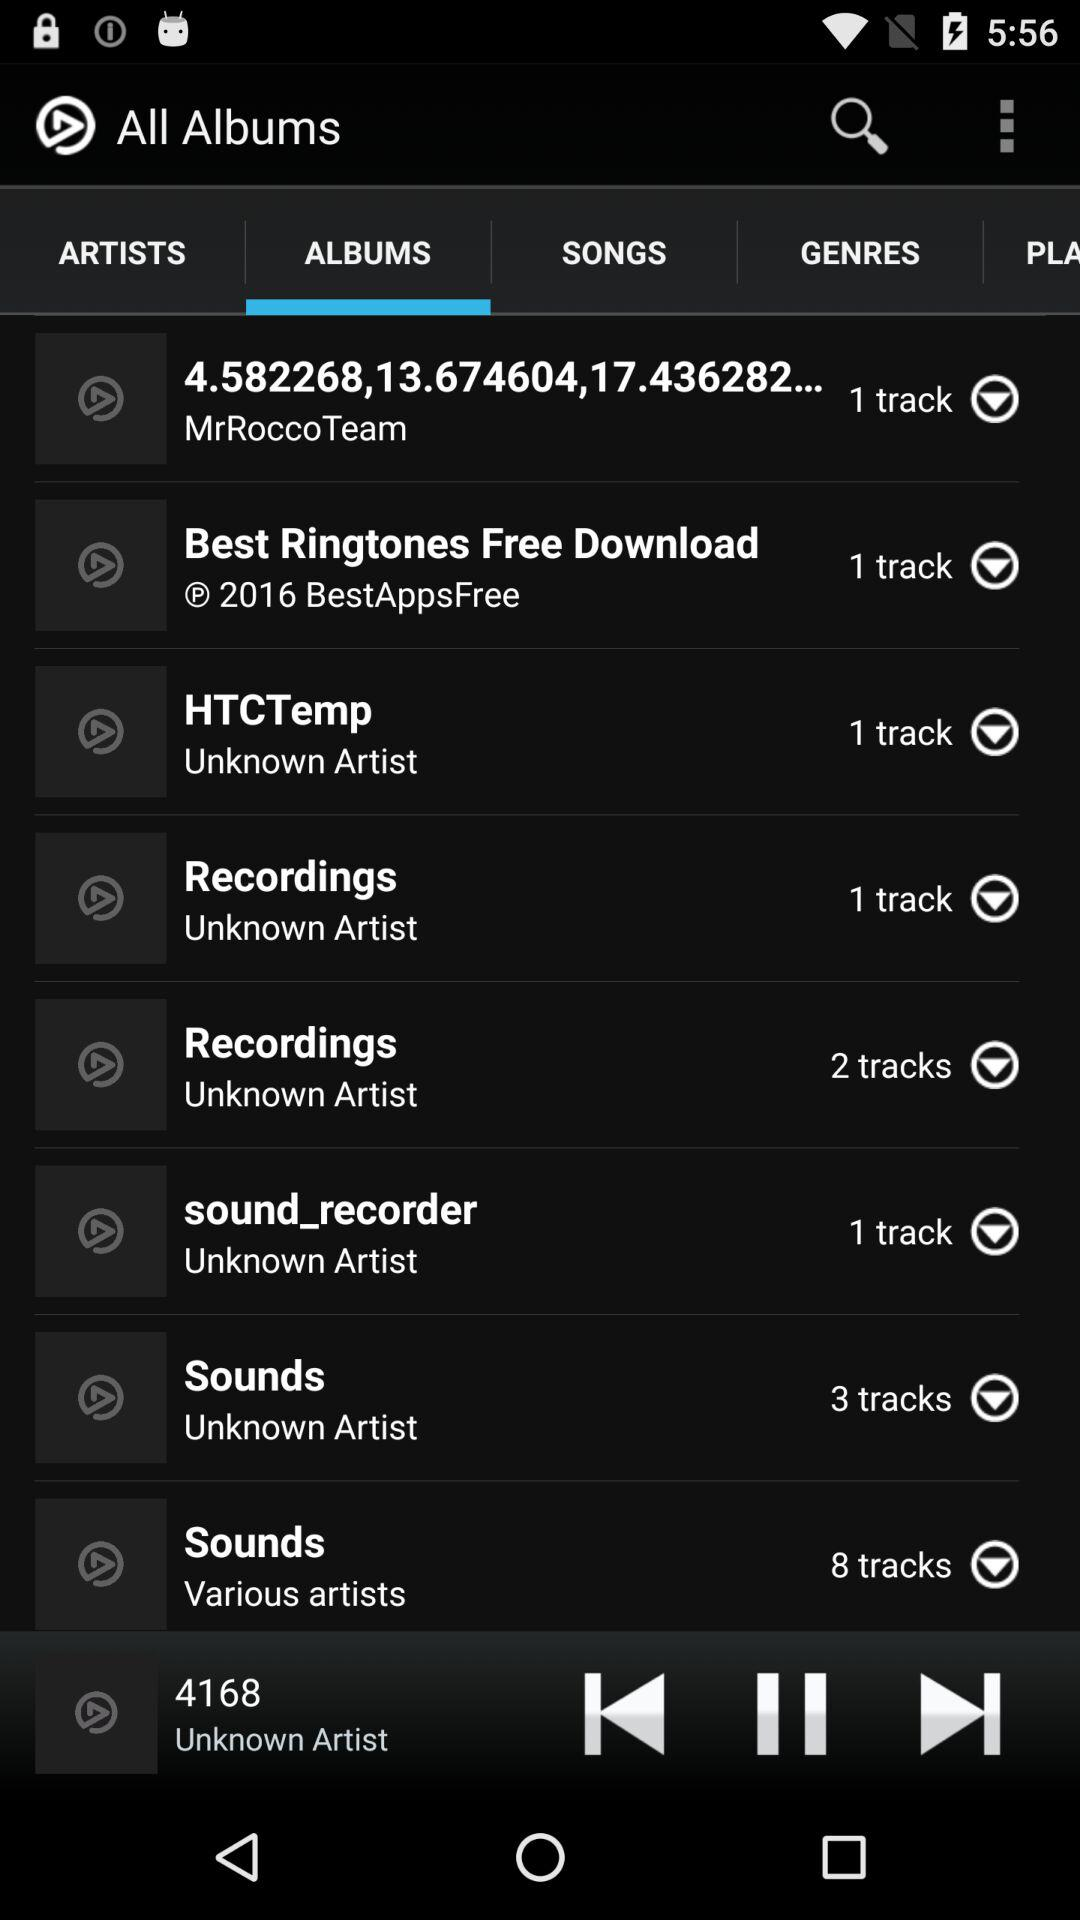Which folder contain 8 track?
When the provided information is insufficient, respond with <no answer>. <no answer> 